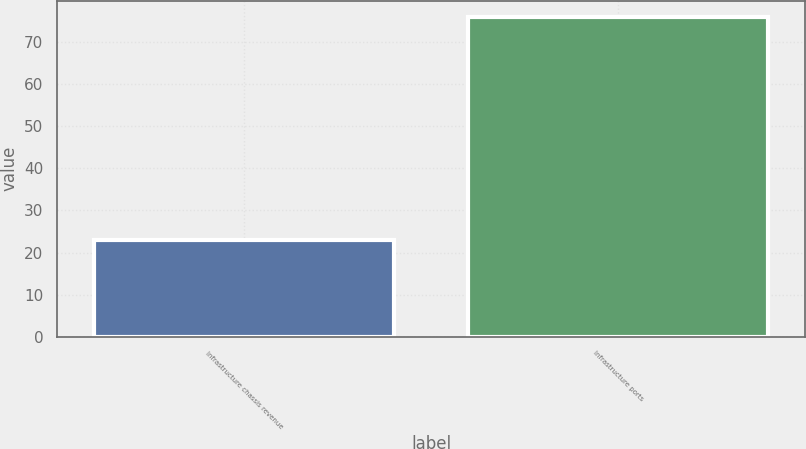<chart> <loc_0><loc_0><loc_500><loc_500><bar_chart><fcel>Infrastructure chassis revenue<fcel>Infrastructure ports<nl><fcel>23<fcel>76<nl></chart> 